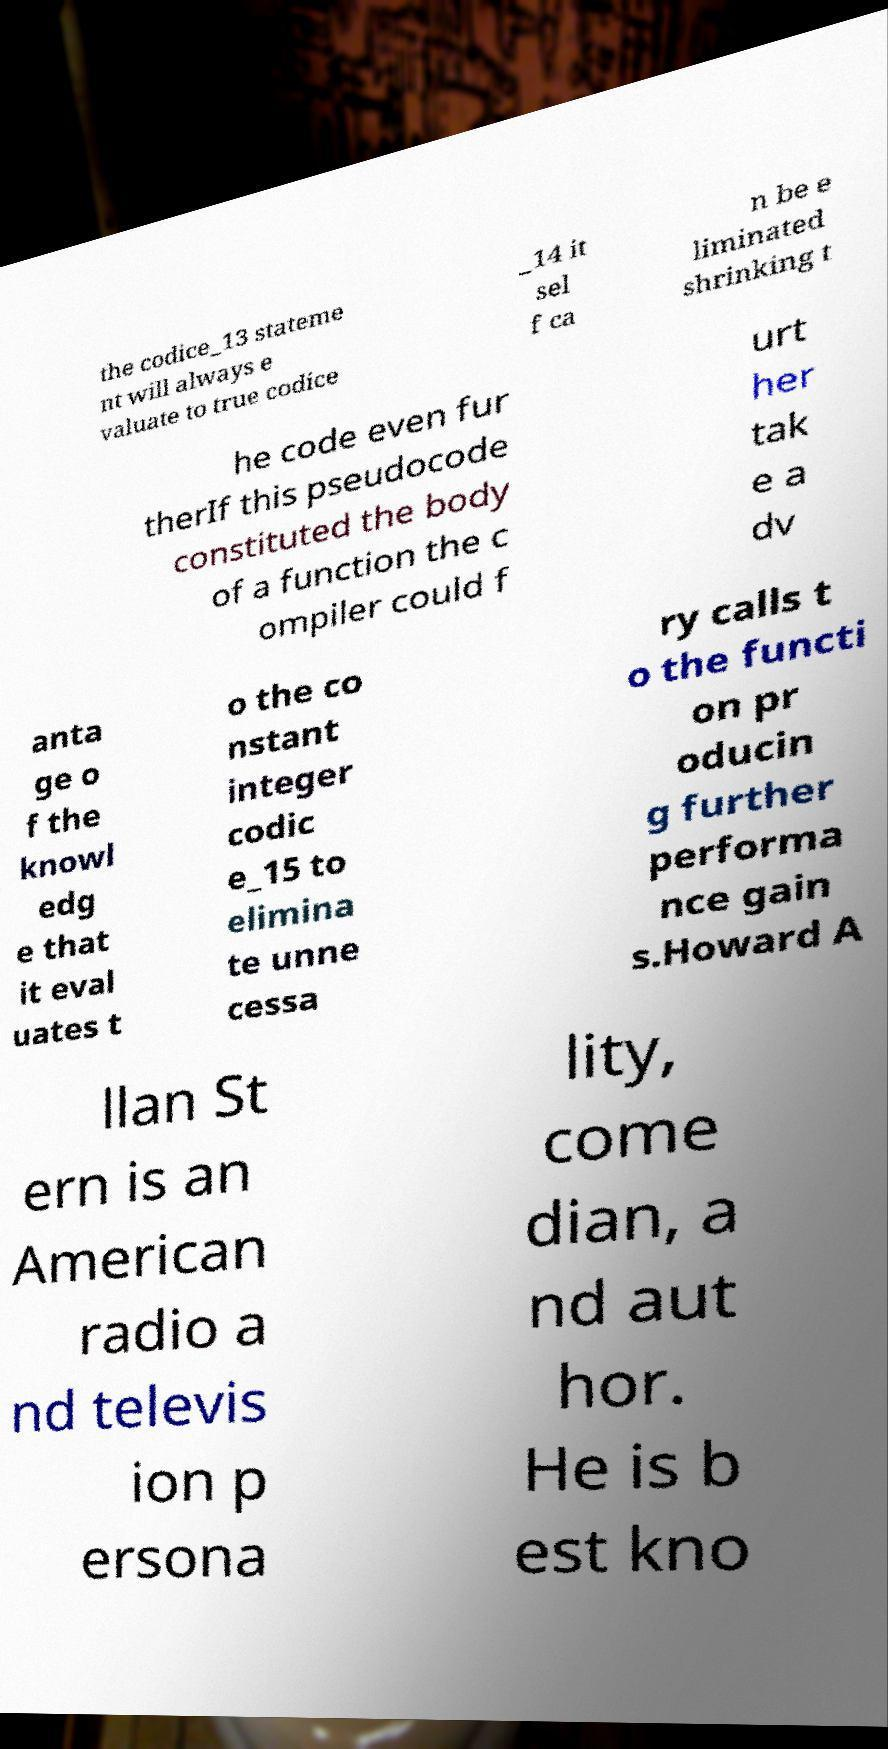Please identify and transcribe the text found in this image. the codice_13 stateme nt will always e valuate to true codice _14 it sel f ca n be e liminated shrinking t he code even fur therIf this pseudocode constituted the body of a function the c ompiler could f urt her tak e a dv anta ge o f the knowl edg e that it eval uates t o the co nstant integer codic e_15 to elimina te unne cessa ry calls t o the functi on pr oducin g further performa nce gain s.Howard A llan St ern is an American radio a nd televis ion p ersona lity, come dian, a nd aut hor. He is b est kno 